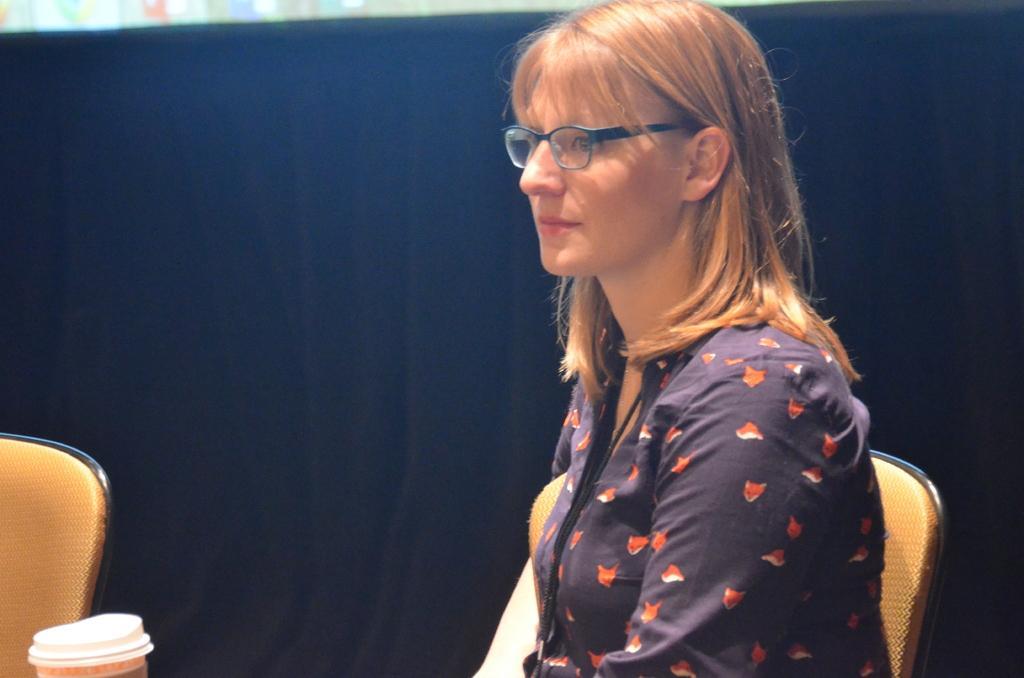Can you describe this image briefly? In this image there is a woman towards the bottom of the image, she is wearing spectacles, there are chairs towards the bottom of the image, there is an object towards the bottom of the image, there is a black colored cloth behind the woman. 